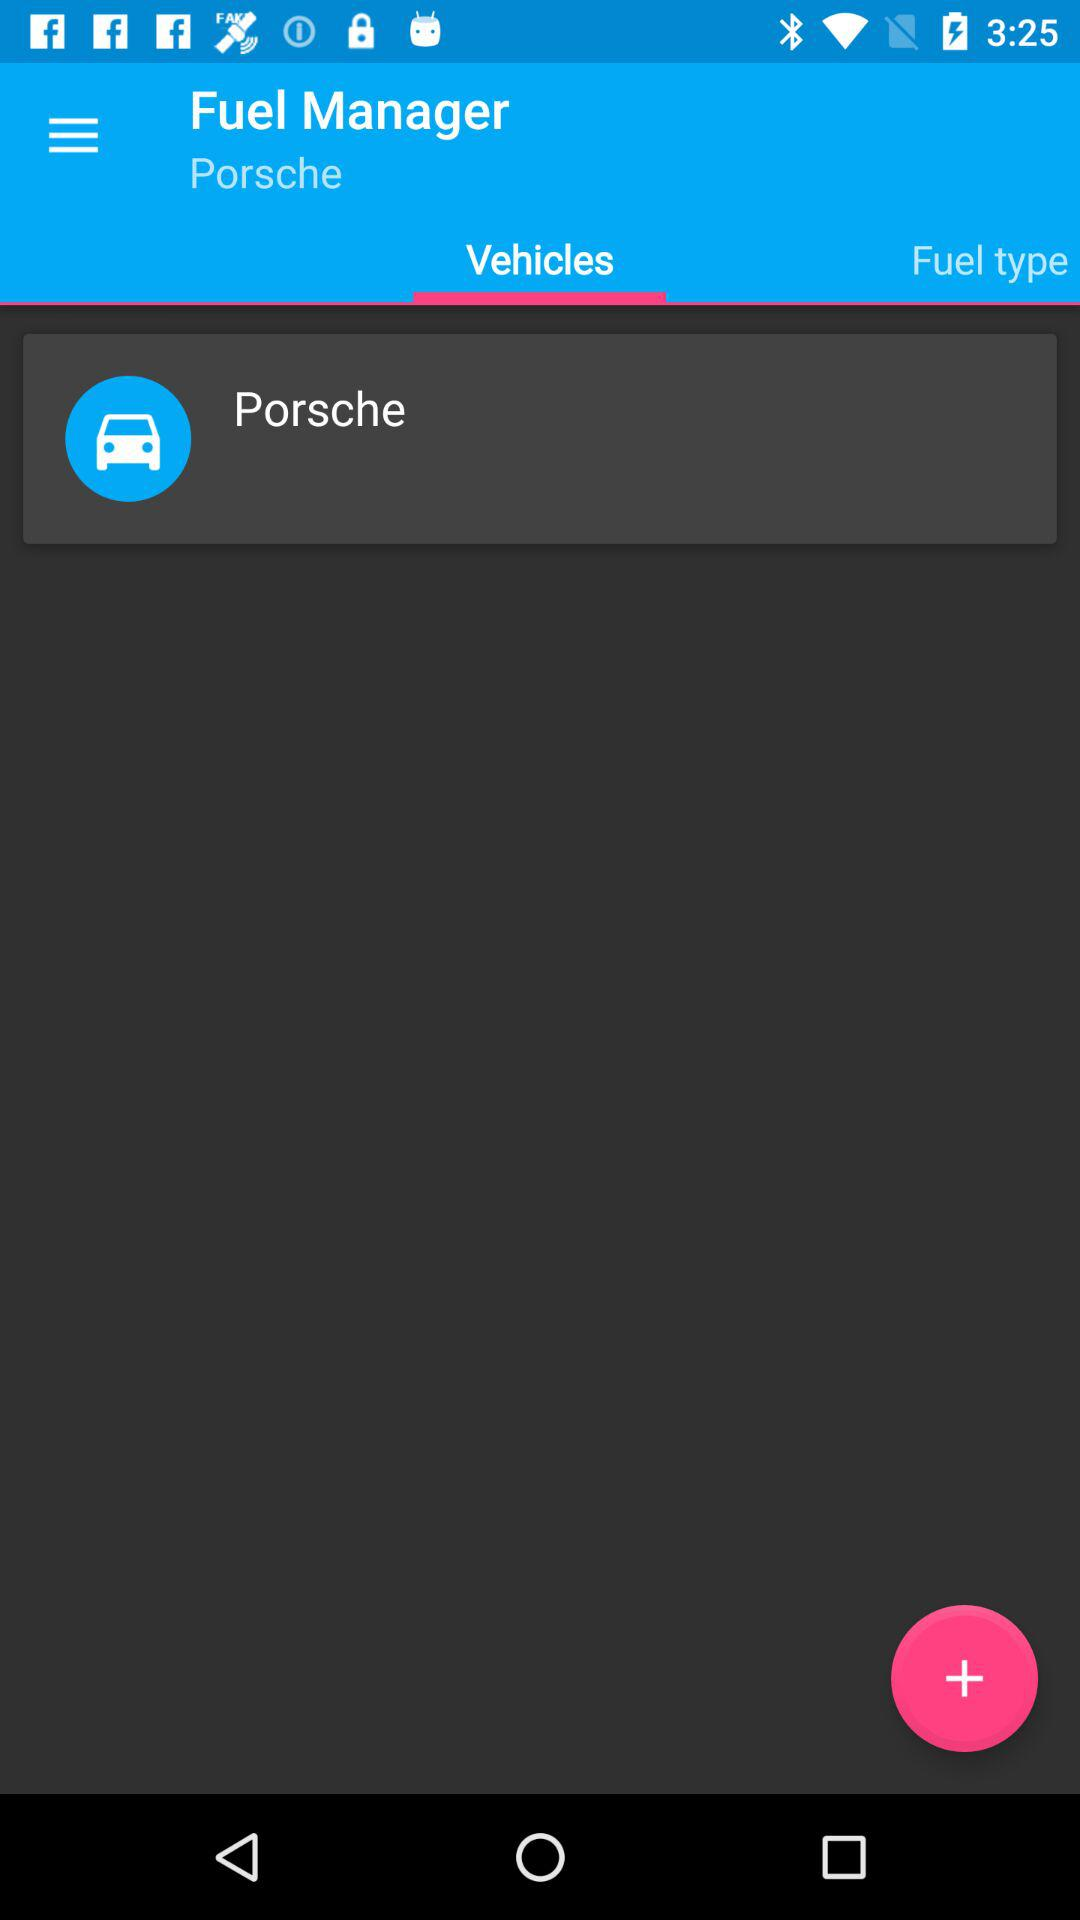What is the vehicle name? The vehicle name is "Porsche". 